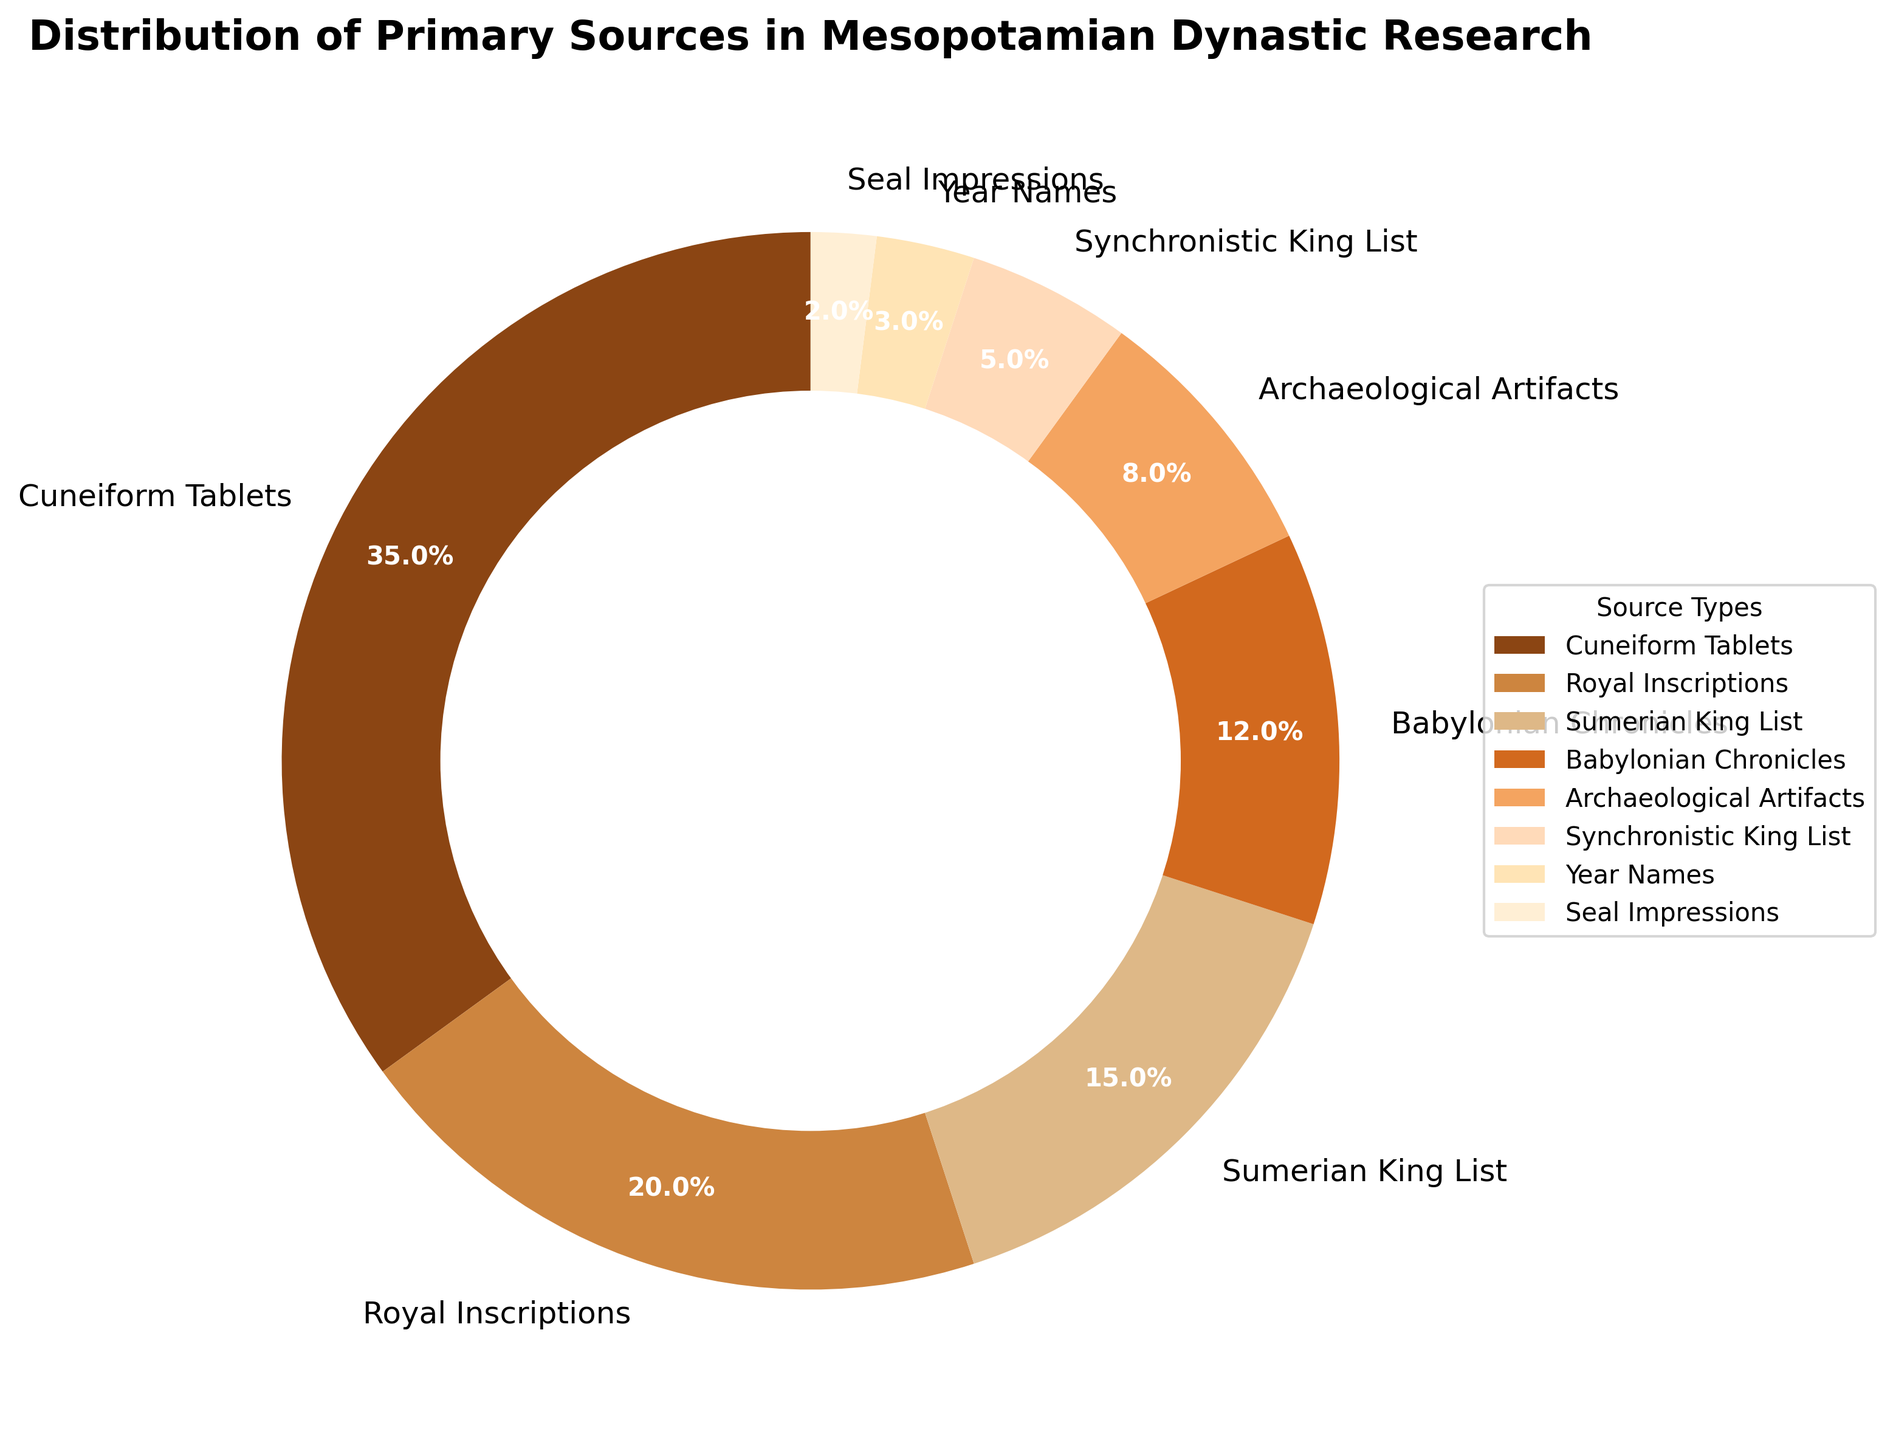What is the source type with the largest percentage? The pie chart shows various source types and their corresponding percentages. The largest section is 35%, which corresponds to "Cuneiform Tablets."
Answer: Cuneiform Tablets Which source types collectively constitute exactly half of the total percentage? To find the source types that add up to 50%, we sum the percentages starting with the largest until we reach 50%. The largest is 35% (Cuneiform Tablets), and adding the next largest, 20% (Royal Inscriptions), results in 55%, which is just over half. Thus, removing the 2nd largest (Royal Inscriptions) does not work. Including the third largest (Sumerian King List, 15%), we try different combinations until "Cuneiform Tablets" and "Sumerian King List" alone do not work (35 + 15 = 50%). Adding "Babylonian Chronicles" (12%), sums up to: 35 + 15 + 12 = 62%. Repeating such trials results in Cuneiform Tablets 35%, Royal Inscriptions 20% (35 + 20)
Answer: Cuneiform Tablets and Royal Inscriptions How many source types individually account for more than 10% of the total? Analyzing the pie chart, the source types with more than 10% are "Cuneiform Tablets" (35%), "Royal Inscriptions" (20%), "Sumerian King List" (15%), and "Babylonian Chronicles" (12%). Hence, there are 4 such types
Answer: 4 By how much does the percentage of Cuneiform Tablets exceed that of Archaeological Artifacts? The percentage for Cuneiform Tablets is 35%, and for Archaeological Artifacts is 8%. Subtracting these values, 35 - 8 results in 27%
Answer: 27% What color is used to represent Royal Inscriptions in the pie chart? Observing the pie chart, "Royal Inscriptions" is represented by the second pie slice which has a brown color.
Answer: Brown What is the total percentage of sources other than Cuneiform Tablets? To determine the total percentage for all sources except Cuneiform Tablets, we subtract the percentage for Cuneiform Tablets from 100%. Therefore, it is 100 - 35 = 65%
Answer: 65% What is the percentage difference between the Synchronistic King List and Year Names? The Synchronistic King List has a percentage of 5%, and Year Names have 3%. Subtracting these values, 5 - 3 results in 2%
Answer: 2% Which source type has the smallest percentage, and what is that percentage? The smallest percentage shown in the pie chart is 2%, which corresponds to "Seal Impressions."
Answer: Seal Impressions, 2% 